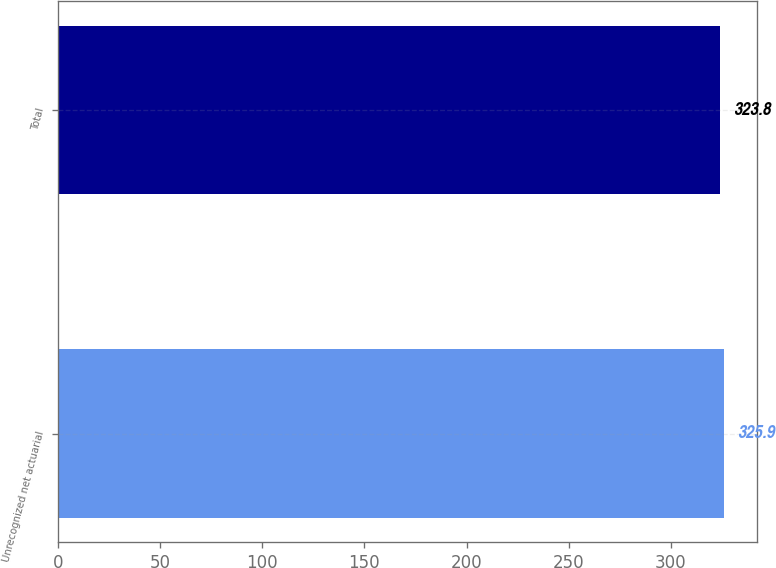Convert chart. <chart><loc_0><loc_0><loc_500><loc_500><bar_chart><fcel>Unrecognized net actuarial<fcel>Total<nl><fcel>325.9<fcel>323.8<nl></chart> 